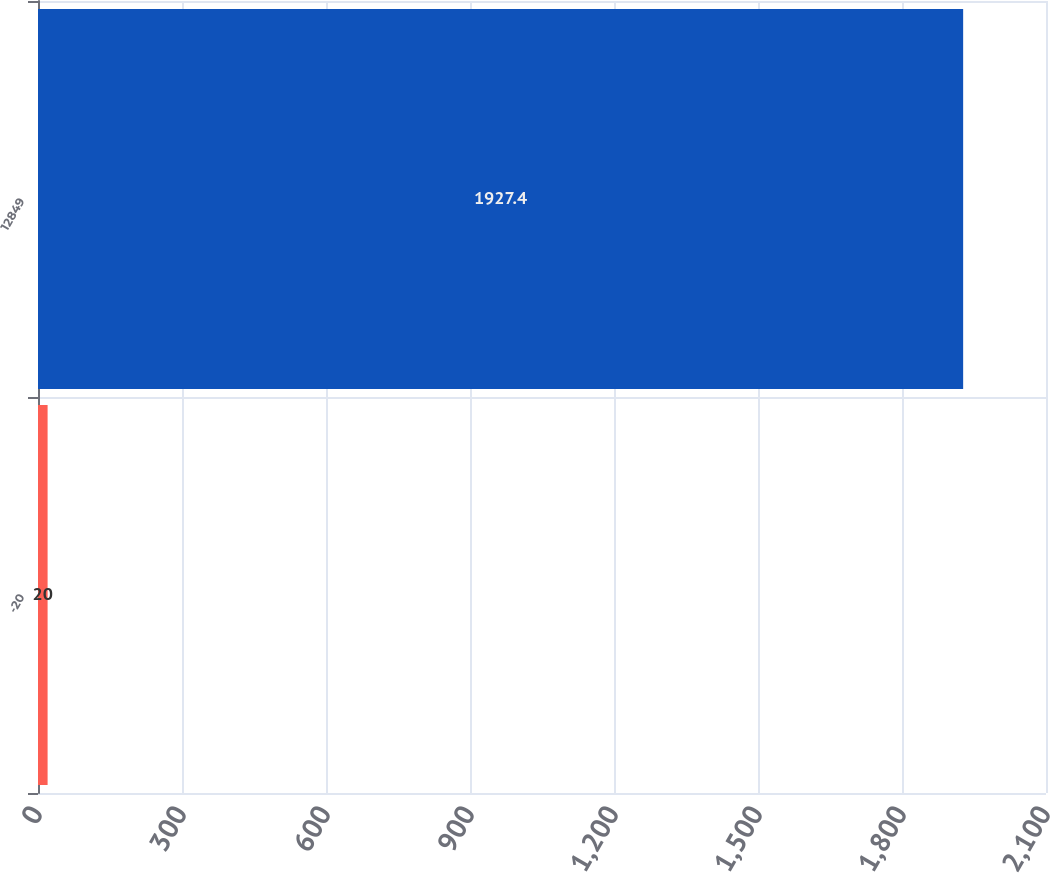Convert chart to OTSL. <chart><loc_0><loc_0><loc_500><loc_500><bar_chart><fcel>-20<fcel>12849<nl><fcel>20<fcel>1927.4<nl></chart> 